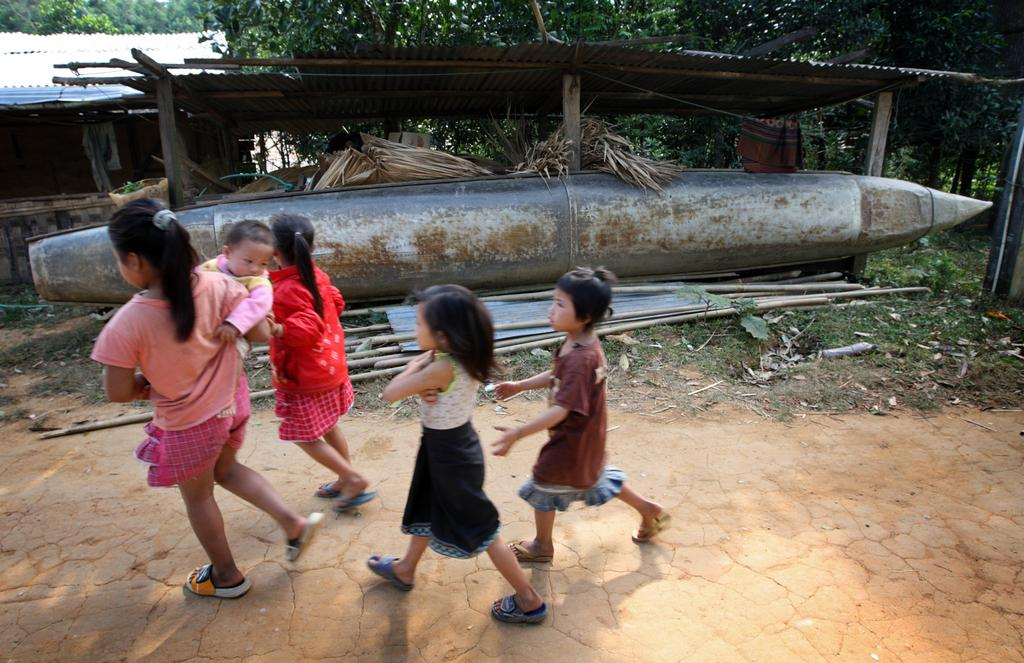Who is present in the image? There are children in the image. What are the children doing? The children are walking. Can you describe the girl in the image? The girl is carrying a baby. What can be seen in the background of the image? There are sheds, trees, and a boat in the background of the image. Are there any other elements in the background of the image? Yes, there are other unspecified things in the background of the image. What system does the grandmother use to communicate with the children in the image? There is no mention of a grandmother or any communication system in the image. 